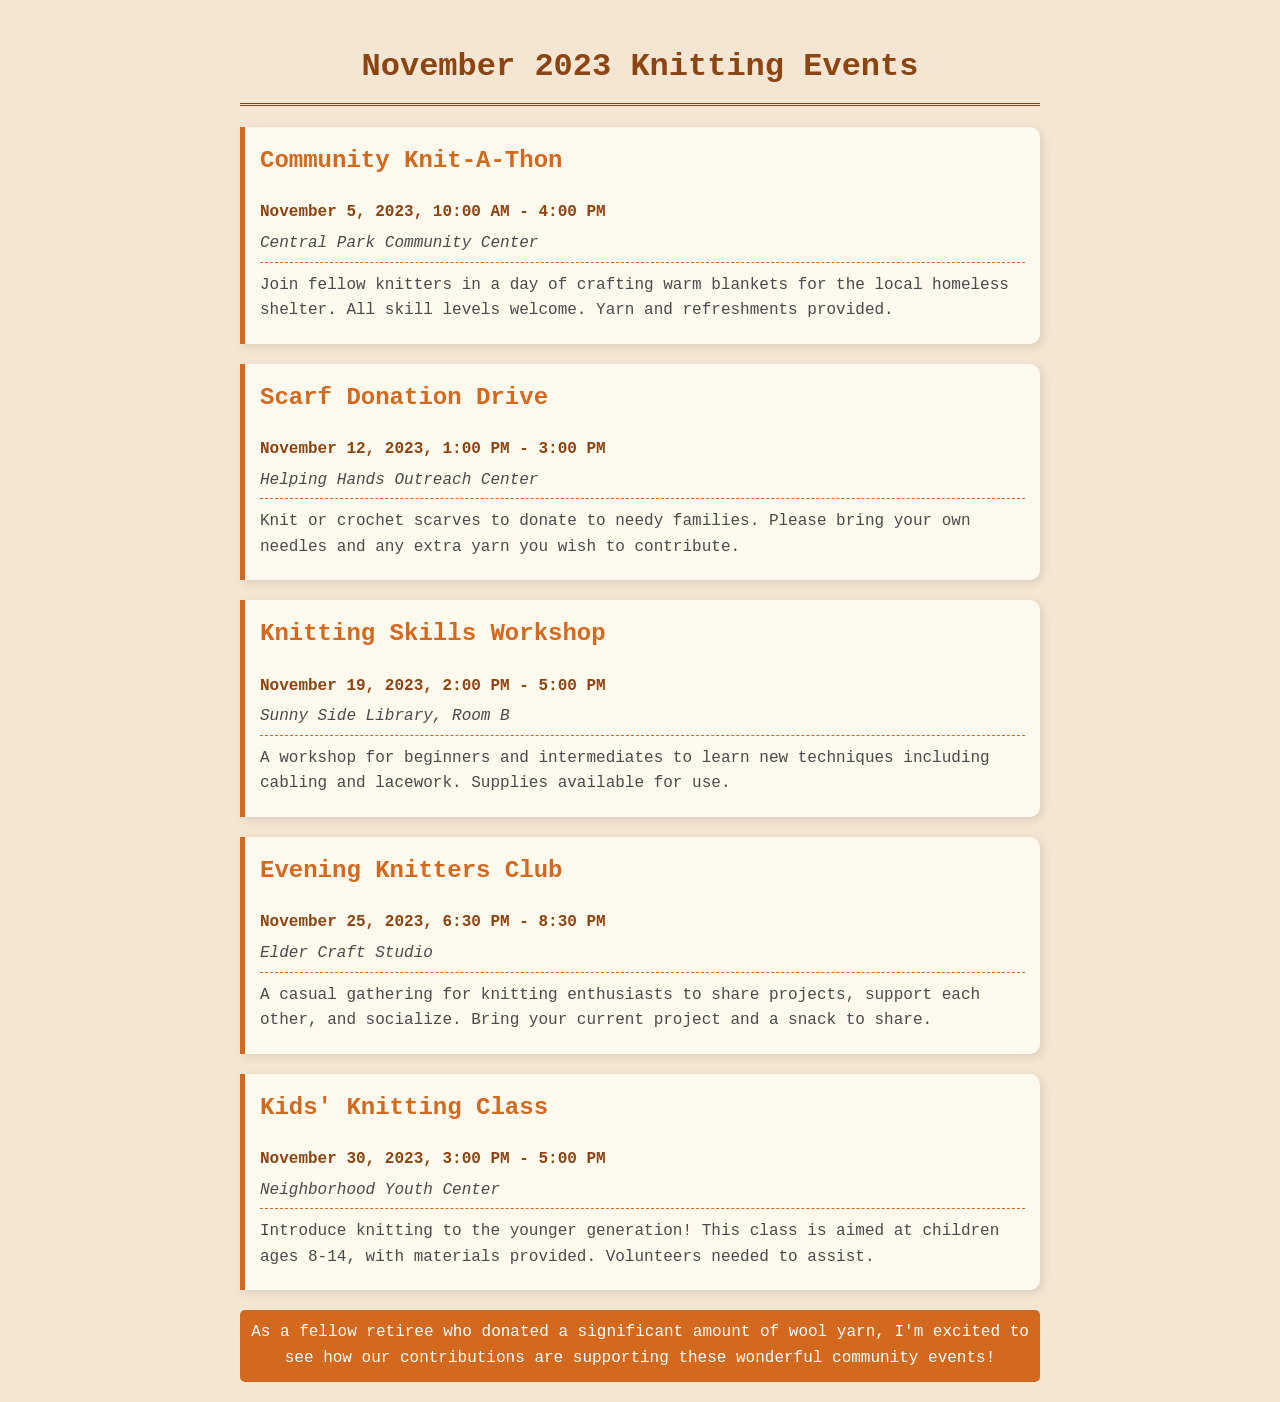What is the date of the Community Knit-A-Thon? The date for the Community Knit-A-Thon is clearly stated in the event section.
Answer: November 5, 2023 What time does the Scarf Donation Drive start? The start time of the Scarf Donation Drive is mentioned in its event details.
Answer: 1:00 PM Where is the Knitting Skills Workshop held? The location of the Knitting Skills Workshop is specified in the event description.
Answer: Sunny Side Library, Room B How long is the Evening Knitters Club event? The duration of the Evening Knitters Club is indicated by its start and end times.
Answer: 2 hours How many events are scheduled for November? The total number of knitting events listed in the document gives the answer.
Answer: 5 What skill levels are welcome at the Community Knit-A-Thon? This information is given in the description of the Community Knit-A-Thon event.
Answer: All skill levels What is required from participants for the Scarf Donation Drive? The description of the Scarf Donation Drive lists what participants should bring.
Answer: Own needles and extra yarn Who can attend the Kids' Knitting Class? The intended age group for the Kids' Knitting Class is mentioned in the event details.
Answer: Ages 8-14 What type of gathering is the Evening Knitters Club? The nature of the Evening Knitters Club is defined in its description.
Answer: Casual gathering 